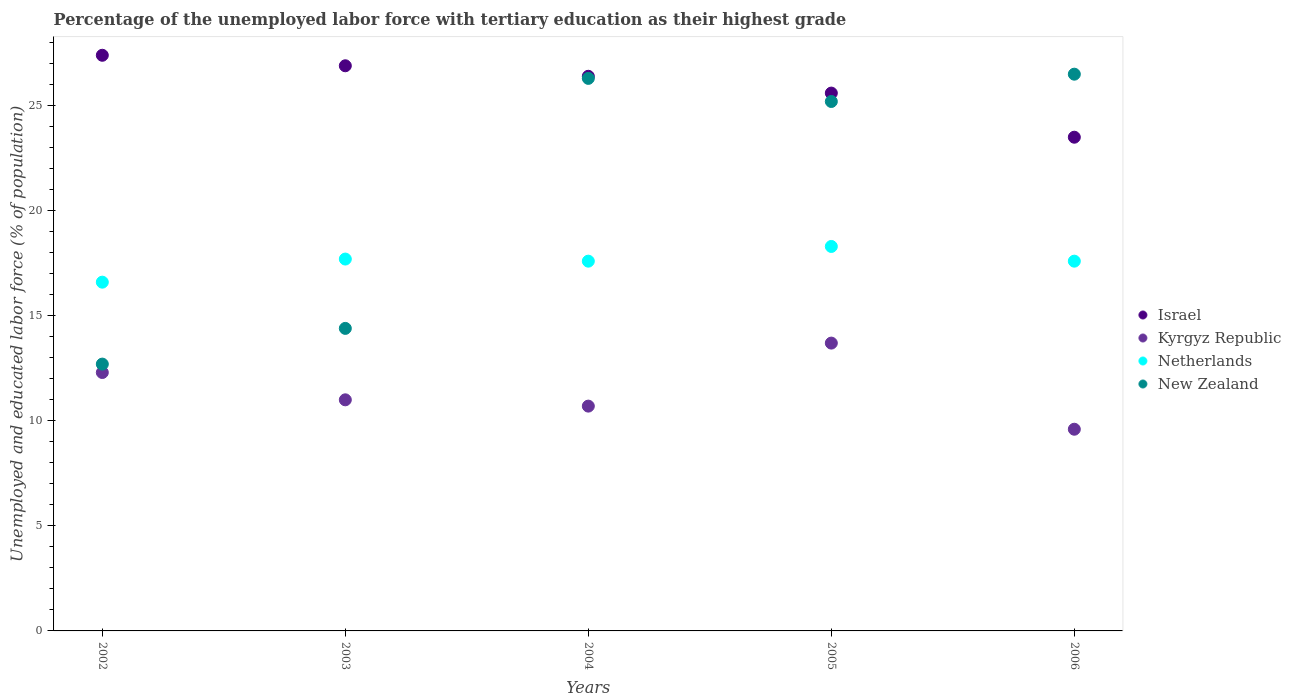How many different coloured dotlines are there?
Provide a short and direct response. 4. Is the number of dotlines equal to the number of legend labels?
Provide a short and direct response. Yes. What is the percentage of the unemployed labor force with tertiary education in Kyrgyz Republic in 2005?
Provide a succinct answer. 13.7. Across all years, what is the maximum percentage of the unemployed labor force with tertiary education in Kyrgyz Republic?
Your answer should be very brief. 13.7. Across all years, what is the minimum percentage of the unemployed labor force with tertiary education in Kyrgyz Republic?
Offer a very short reply. 9.6. In which year was the percentage of the unemployed labor force with tertiary education in Israel minimum?
Make the answer very short. 2006. What is the total percentage of the unemployed labor force with tertiary education in Kyrgyz Republic in the graph?
Provide a short and direct response. 57.3. What is the difference between the percentage of the unemployed labor force with tertiary education in Israel in 2004 and that in 2006?
Your answer should be compact. 2.9. What is the difference between the percentage of the unemployed labor force with tertiary education in Netherlands in 2002 and the percentage of the unemployed labor force with tertiary education in Israel in 2003?
Ensure brevity in your answer.  -10.3. What is the average percentage of the unemployed labor force with tertiary education in Netherlands per year?
Give a very brief answer. 17.56. In the year 2003, what is the difference between the percentage of the unemployed labor force with tertiary education in Israel and percentage of the unemployed labor force with tertiary education in New Zealand?
Keep it short and to the point. 12.5. In how many years, is the percentage of the unemployed labor force with tertiary education in Israel greater than 21 %?
Your answer should be compact. 5. What is the ratio of the percentage of the unemployed labor force with tertiary education in Israel in 2002 to that in 2006?
Your answer should be very brief. 1.17. What is the difference between the highest and the second highest percentage of the unemployed labor force with tertiary education in Israel?
Keep it short and to the point. 0.5. What is the difference between the highest and the lowest percentage of the unemployed labor force with tertiary education in Netherlands?
Your answer should be very brief. 1.7. In how many years, is the percentage of the unemployed labor force with tertiary education in Kyrgyz Republic greater than the average percentage of the unemployed labor force with tertiary education in Kyrgyz Republic taken over all years?
Your answer should be very brief. 2. Is the sum of the percentage of the unemployed labor force with tertiary education in Netherlands in 2003 and 2005 greater than the maximum percentage of the unemployed labor force with tertiary education in Kyrgyz Republic across all years?
Provide a succinct answer. Yes. Is it the case that in every year, the sum of the percentage of the unemployed labor force with tertiary education in Netherlands and percentage of the unemployed labor force with tertiary education in New Zealand  is greater than the sum of percentage of the unemployed labor force with tertiary education in Israel and percentage of the unemployed labor force with tertiary education in Kyrgyz Republic?
Ensure brevity in your answer.  No. Is it the case that in every year, the sum of the percentage of the unemployed labor force with tertiary education in New Zealand and percentage of the unemployed labor force with tertiary education in Kyrgyz Republic  is greater than the percentage of the unemployed labor force with tertiary education in Netherlands?
Offer a terse response. Yes. Does the percentage of the unemployed labor force with tertiary education in Kyrgyz Republic monotonically increase over the years?
Offer a terse response. No. Is the percentage of the unemployed labor force with tertiary education in Israel strictly greater than the percentage of the unemployed labor force with tertiary education in New Zealand over the years?
Your answer should be compact. No. Is the percentage of the unemployed labor force with tertiary education in Israel strictly less than the percentage of the unemployed labor force with tertiary education in New Zealand over the years?
Ensure brevity in your answer.  No. How many dotlines are there?
Provide a short and direct response. 4. Are the values on the major ticks of Y-axis written in scientific E-notation?
Your response must be concise. No. Does the graph contain any zero values?
Give a very brief answer. No. Where does the legend appear in the graph?
Provide a short and direct response. Center right. How are the legend labels stacked?
Give a very brief answer. Vertical. What is the title of the graph?
Make the answer very short. Percentage of the unemployed labor force with tertiary education as their highest grade. Does "Grenada" appear as one of the legend labels in the graph?
Offer a terse response. No. What is the label or title of the Y-axis?
Your response must be concise. Unemployed and educated labor force (% of population). What is the Unemployed and educated labor force (% of population) of Israel in 2002?
Provide a short and direct response. 27.4. What is the Unemployed and educated labor force (% of population) in Kyrgyz Republic in 2002?
Offer a terse response. 12.3. What is the Unemployed and educated labor force (% of population) of Netherlands in 2002?
Ensure brevity in your answer.  16.6. What is the Unemployed and educated labor force (% of population) of New Zealand in 2002?
Your answer should be very brief. 12.7. What is the Unemployed and educated labor force (% of population) in Israel in 2003?
Give a very brief answer. 26.9. What is the Unemployed and educated labor force (% of population) in Netherlands in 2003?
Your response must be concise. 17.7. What is the Unemployed and educated labor force (% of population) of New Zealand in 2003?
Your response must be concise. 14.4. What is the Unemployed and educated labor force (% of population) in Israel in 2004?
Offer a terse response. 26.4. What is the Unemployed and educated labor force (% of population) in Kyrgyz Republic in 2004?
Give a very brief answer. 10.7. What is the Unemployed and educated labor force (% of population) of Netherlands in 2004?
Give a very brief answer. 17.6. What is the Unemployed and educated labor force (% of population) of New Zealand in 2004?
Offer a terse response. 26.3. What is the Unemployed and educated labor force (% of population) of Israel in 2005?
Offer a terse response. 25.6. What is the Unemployed and educated labor force (% of population) of Kyrgyz Republic in 2005?
Provide a succinct answer. 13.7. What is the Unemployed and educated labor force (% of population) of Netherlands in 2005?
Offer a very short reply. 18.3. What is the Unemployed and educated labor force (% of population) in New Zealand in 2005?
Provide a short and direct response. 25.2. What is the Unemployed and educated labor force (% of population) in Kyrgyz Republic in 2006?
Keep it short and to the point. 9.6. What is the Unemployed and educated labor force (% of population) of Netherlands in 2006?
Your response must be concise. 17.6. What is the Unemployed and educated labor force (% of population) in New Zealand in 2006?
Your answer should be very brief. 26.5. Across all years, what is the maximum Unemployed and educated labor force (% of population) of Israel?
Your response must be concise. 27.4. Across all years, what is the maximum Unemployed and educated labor force (% of population) in Kyrgyz Republic?
Keep it short and to the point. 13.7. Across all years, what is the maximum Unemployed and educated labor force (% of population) in Netherlands?
Offer a very short reply. 18.3. Across all years, what is the minimum Unemployed and educated labor force (% of population) in Kyrgyz Republic?
Offer a terse response. 9.6. Across all years, what is the minimum Unemployed and educated labor force (% of population) in Netherlands?
Give a very brief answer. 16.6. Across all years, what is the minimum Unemployed and educated labor force (% of population) of New Zealand?
Your response must be concise. 12.7. What is the total Unemployed and educated labor force (% of population) of Israel in the graph?
Give a very brief answer. 129.8. What is the total Unemployed and educated labor force (% of population) in Kyrgyz Republic in the graph?
Your answer should be very brief. 57.3. What is the total Unemployed and educated labor force (% of population) of Netherlands in the graph?
Provide a succinct answer. 87.8. What is the total Unemployed and educated labor force (% of population) of New Zealand in the graph?
Offer a very short reply. 105.1. What is the difference between the Unemployed and educated labor force (% of population) in Israel in 2002 and that in 2003?
Your answer should be very brief. 0.5. What is the difference between the Unemployed and educated labor force (% of population) of Netherlands in 2002 and that in 2003?
Ensure brevity in your answer.  -1.1. What is the difference between the Unemployed and educated labor force (% of population) of New Zealand in 2002 and that in 2004?
Your response must be concise. -13.6. What is the difference between the Unemployed and educated labor force (% of population) in Israel in 2002 and that in 2005?
Provide a succinct answer. 1.8. What is the difference between the Unemployed and educated labor force (% of population) of Kyrgyz Republic in 2002 and that in 2005?
Give a very brief answer. -1.4. What is the difference between the Unemployed and educated labor force (% of population) of Netherlands in 2002 and that in 2005?
Your response must be concise. -1.7. What is the difference between the Unemployed and educated labor force (% of population) of Israel in 2002 and that in 2006?
Your answer should be very brief. 3.9. What is the difference between the Unemployed and educated labor force (% of population) in Netherlands in 2002 and that in 2006?
Your response must be concise. -1. What is the difference between the Unemployed and educated labor force (% of population) in New Zealand in 2002 and that in 2006?
Offer a terse response. -13.8. What is the difference between the Unemployed and educated labor force (% of population) in Israel in 2003 and that in 2004?
Make the answer very short. 0.5. What is the difference between the Unemployed and educated labor force (% of population) of New Zealand in 2003 and that in 2004?
Your response must be concise. -11.9. What is the difference between the Unemployed and educated labor force (% of population) of Israel in 2003 and that in 2005?
Ensure brevity in your answer.  1.3. What is the difference between the Unemployed and educated labor force (% of population) of Netherlands in 2003 and that in 2005?
Your response must be concise. -0.6. What is the difference between the Unemployed and educated labor force (% of population) in Israel in 2004 and that in 2006?
Ensure brevity in your answer.  2.9. What is the difference between the Unemployed and educated labor force (% of population) of Netherlands in 2004 and that in 2006?
Your answer should be very brief. 0. What is the difference between the Unemployed and educated labor force (% of population) in New Zealand in 2005 and that in 2006?
Your response must be concise. -1.3. What is the difference between the Unemployed and educated labor force (% of population) in Israel in 2002 and the Unemployed and educated labor force (% of population) in Kyrgyz Republic in 2003?
Offer a very short reply. 16.4. What is the difference between the Unemployed and educated labor force (% of population) of Israel in 2002 and the Unemployed and educated labor force (% of population) of New Zealand in 2003?
Your response must be concise. 13. What is the difference between the Unemployed and educated labor force (% of population) in Kyrgyz Republic in 2002 and the Unemployed and educated labor force (% of population) in Netherlands in 2003?
Ensure brevity in your answer.  -5.4. What is the difference between the Unemployed and educated labor force (% of population) of Kyrgyz Republic in 2002 and the Unemployed and educated labor force (% of population) of New Zealand in 2003?
Give a very brief answer. -2.1. What is the difference between the Unemployed and educated labor force (% of population) in Netherlands in 2002 and the Unemployed and educated labor force (% of population) in New Zealand in 2003?
Ensure brevity in your answer.  2.2. What is the difference between the Unemployed and educated labor force (% of population) in Israel in 2002 and the Unemployed and educated labor force (% of population) in New Zealand in 2004?
Keep it short and to the point. 1.1. What is the difference between the Unemployed and educated labor force (% of population) of Kyrgyz Republic in 2002 and the Unemployed and educated labor force (% of population) of Netherlands in 2004?
Make the answer very short. -5.3. What is the difference between the Unemployed and educated labor force (% of population) of Kyrgyz Republic in 2002 and the Unemployed and educated labor force (% of population) of New Zealand in 2004?
Your answer should be compact. -14. What is the difference between the Unemployed and educated labor force (% of population) in Israel in 2002 and the Unemployed and educated labor force (% of population) in Kyrgyz Republic in 2005?
Your answer should be compact. 13.7. What is the difference between the Unemployed and educated labor force (% of population) in Kyrgyz Republic in 2002 and the Unemployed and educated labor force (% of population) in Netherlands in 2005?
Your answer should be very brief. -6. What is the difference between the Unemployed and educated labor force (% of population) in Kyrgyz Republic in 2002 and the Unemployed and educated labor force (% of population) in New Zealand in 2005?
Make the answer very short. -12.9. What is the difference between the Unemployed and educated labor force (% of population) of Israel in 2002 and the Unemployed and educated labor force (% of population) of Kyrgyz Republic in 2006?
Offer a very short reply. 17.8. What is the difference between the Unemployed and educated labor force (% of population) of Israel in 2002 and the Unemployed and educated labor force (% of population) of Netherlands in 2006?
Provide a short and direct response. 9.8. What is the difference between the Unemployed and educated labor force (% of population) of Israel in 2002 and the Unemployed and educated labor force (% of population) of New Zealand in 2006?
Offer a terse response. 0.9. What is the difference between the Unemployed and educated labor force (% of population) in Kyrgyz Republic in 2002 and the Unemployed and educated labor force (% of population) in Netherlands in 2006?
Your response must be concise. -5.3. What is the difference between the Unemployed and educated labor force (% of population) of Kyrgyz Republic in 2002 and the Unemployed and educated labor force (% of population) of New Zealand in 2006?
Provide a succinct answer. -14.2. What is the difference between the Unemployed and educated labor force (% of population) of Israel in 2003 and the Unemployed and educated labor force (% of population) of Kyrgyz Republic in 2004?
Keep it short and to the point. 16.2. What is the difference between the Unemployed and educated labor force (% of population) in Kyrgyz Republic in 2003 and the Unemployed and educated labor force (% of population) in Netherlands in 2004?
Give a very brief answer. -6.6. What is the difference between the Unemployed and educated labor force (% of population) of Kyrgyz Republic in 2003 and the Unemployed and educated labor force (% of population) of New Zealand in 2004?
Offer a terse response. -15.3. What is the difference between the Unemployed and educated labor force (% of population) in Netherlands in 2003 and the Unemployed and educated labor force (% of population) in New Zealand in 2004?
Give a very brief answer. -8.6. What is the difference between the Unemployed and educated labor force (% of population) of Israel in 2003 and the Unemployed and educated labor force (% of population) of Kyrgyz Republic in 2005?
Offer a terse response. 13.2. What is the difference between the Unemployed and educated labor force (% of population) in Israel in 2003 and the Unemployed and educated labor force (% of population) in Netherlands in 2005?
Make the answer very short. 8.6. What is the difference between the Unemployed and educated labor force (% of population) of Israel in 2003 and the Unemployed and educated labor force (% of population) of New Zealand in 2005?
Your answer should be very brief. 1.7. What is the difference between the Unemployed and educated labor force (% of population) of Kyrgyz Republic in 2003 and the Unemployed and educated labor force (% of population) of Netherlands in 2005?
Provide a short and direct response. -7.3. What is the difference between the Unemployed and educated labor force (% of population) in Kyrgyz Republic in 2003 and the Unemployed and educated labor force (% of population) in New Zealand in 2005?
Offer a terse response. -14.2. What is the difference between the Unemployed and educated labor force (% of population) of Netherlands in 2003 and the Unemployed and educated labor force (% of population) of New Zealand in 2005?
Provide a short and direct response. -7.5. What is the difference between the Unemployed and educated labor force (% of population) of Israel in 2003 and the Unemployed and educated labor force (% of population) of Kyrgyz Republic in 2006?
Your answer should be compact. 17.3. What is the difference between the Unemployed and educated labor force (% of population) in Israel in 2003 and the Unemployed and educated labor force (% of population) in Netherlands in 2006?
Provide a succinct answer. 9.3. What is the difference between the Unemployed and educated labor force (% of population) of Kyrgyz Republic in 2003 and the Unemployed and educated labor force (% of population) of New Zealand in 2006?
Your answer should be compact. -15.5. What is the difference between the Unemployed and educated labor force (% of population) in Netherlands in 2003 and the Unemployed and educated labor force (% of population) in New Zealand in 2006?
Ensure brevity in your answer.  -8.8. What is the difference between the Unemployed and educated labor force (% of population) of Israel in 2004 and the Unemployed and educated labor force (% of population) of Kyrgyz Republic in 2005?
Your answer should be very brief. 12.7. What is the difference between the Unemployed and educated labor force (% of population) in Israel in 2004 and the Unemployed and educated labor force (% of population) in New Zealand in 2005?
Ensure brevity in your answer.  1.2. What is the difference between the Unemployed and educated labor force (% of population) in Kyrgyz Republic in 2004 and the Unemployed and educated labor force (% of population) in New Zealand in 2005?
Offer a very short reply. -14.5. What is the difference between the Unemployed and educated labor force (% of population) in Netherlands in 2004 and the Unemployed and educated labor force (% of population) in New Zealand in 2005?
Ensure brevity in your answer.  -7.6. What is the difference between the Unemployed and educated labor force (% of population) in Israel in 2004 and the Unemployed and educated labor force (% of population) in Netherlands in 2006?
Provide a succinct answer. 8.8. What is the difference between the Unemployed and educated labor force (% of population) of Kyrgyz Republic in 2004 and the Unemployed and educated labor force (% of population) of Netherlands in 2006?
Provide a short and direct response. -6.9. What is the difference between the Unemployed and educated labor force (% of population) of Kyrgyz Republic in 2004 and the Unemployed and educated labor force (% of population) of New Zealand in 2006?
Your response must be concise. -15.8. What is the difference between the Unemployed and educated labor force (% of population) of Netherlands in 2004 and the Unemployed and educated labor force (% of population) of New Zealand in 2006?
Keep it short and to the point. -8.9. What is the difference between the Unemployed and educated labor force (% of population) of Israel in 2005 and the Unemployed and educated labor force (% of population) of Kyrgyz Republic in 2006?
Ensure brevity in your answer.  16. What is the difference between the Unemployed and educated labor force (% of population) of Israel in 2005 and the Unemployed and educated labor force (% of population) of Netherlands in 2006?
Offer a very short reply. 8. What is the difference between the Unemployed and educated labor force (% of population) of Netherlands in 2005 and the Unemployed and educated labor force (% of population) of New Zealand in 2006?
Keep it short and to the point. -8.2. What is the average Unemployed and educated labor force (% of population) of Israel per year?
Ensure brevity in your answer.  25.96. What is the average Unemployed and educated labor force (% of population) of Kyrgyz Republic per year?
Ensure brevity in your answer.  11.46. What is the average Unemployed and educated labor force (% of population) of Netherlands per year?
Offer a terse response. 17.56. What is the average Unemployed and educated labor force (% of population) in New Zealand per year?
Offer a terse response. 21.02. In the year 2002, what is the difference between the Unemployed and educated labor force (% of population) of Israel and Unemployed and educated labor force (% of population) of New Zealand?
Provide a short and direct response. 14.7. In the year 2002, what is the difference between the Unemployed and educated labor force (% of population) in Kyrgyz Republic and Unemployed and educated labor force (% of population) in Netherlands?
Your response must be concise. -4.3. In the year 2002, what is the difference between the Unemployed and educated labor force (% of population) in Kyrgyz Republic and Unemployed and educated labor force (% of population) in New Zealand?
Offer a very short reply. -0.4. In the year 2002, what is the difference between the Unemployed and educated labor force (% of population) in Netherlands and Unemployed and educated labor force (% of population) in New Zealand?
Your answer should be compact. 3.9. In the year 2003, what is the difference between the Unemployed and educated labor force (% of population) in Israel and Unemployed and educated labor force (% of population) in Kyrgyz Republic?
Ensure brevity in your answer.  15.9. In the year 2003, what is the difference between the Unemployed and educated labor force (% of population) in Israel and Unemployed and educated labor force (% of population) in Netherlands?
Your answer should be compact. 9.2. In the year 2003, what is the difference between the Unemployed and educated labor force (% of population) of Kyrgyz Republic and Unemployed and educated labor force (% of population) of New Zealand?
Ensure brevity in your answer.  -3.4. In the year 2003, what is the difference between the Unemployed and educated labor force (% of population) in Netherlands and Unemployed and educated labor force (% of population) in New Zealand?
Make the answer very short. 3.3. In the year 2004, what is the difference between the Unemployed and educated labor force (% of population) of Israel and Unemployed and educated labor force (% of population) of Netherlands?
Your answer should be very brief. 8.8. In the year 2004, what is the difference between the Unemployed and educated labor force (% of population) in Israel and Unemployed and educated labor force (% of population) in New Zealand?
Make the answer very short. 0.1. In the year 2004, what is the difference between the Unemployed and educated labor force (% of population) in Kyrgyz Republic and Unemployed and educated labor force (% of population) in Netherlands?
Provide a short and direct response. -6.9. In the year 2004, what is the difference between the Unemployed and educated labor force (% of population) of Kyrgyz Republic and Unemployed and educated labor force (% of population) of New Zealand?
Your response must be concise. -15.6. In the year 2004, what is the difference between the Unemployed and educated labor force (% of population) of Netherlands and Unemployed and educated labor force (% of population) of New Zealand?
Give a very brief answer. -8.7. In the year 2005, what is the difference between the Unemployed and educated labor force (% of population) of Israel and Unemployed and educated labor force (% of population) of Netherlands?
Make the answer very short. 7.3. In the year 2005, what is the difference between the Unemployed and educated labor force (% of population) of Israel and Unemployed and educated labor force (% of population) of New Zealand?
Ensure brevity in your answer.  0.4. In the year 2005, what is the difference between the Unemployed and educated labor force (% of population) in Kyrgyz Republic and Unemployed and educated labor force (% of population) in Netherlands?
Provide a succinct answer. -4.6. In the year 2005, what is the difference between the Unemployed and educated labor force (% of population) of Kyrgyz Republic and Unemployed and educated labor force (% of population) of New Zealand?
Keep it short and to the point. -11.5. In the year 2005, what is the difference between the Unemployed and educated labor force (% of population) of Netherlands and Unemployed and educated labor force (% of population) of New Zealand?
Provide a short and direct response. -6.9. In the year 2006, what is the difference between the Unemployed and educated labor force (% of population) in Israel and Unemployed and educated labor force (% of population) in Kyrgyz Republic?
Your response must be concise. 13.9. In the year 2006, what is the difference between the Unemployed and educated labor force (% of population) in Israel and Unemployed and educated labor force (% of population) in Netherlands?
Offer a terse response. 5.9. In the year 2006, what is the difference between the Unemployed and educated labor force (% of population) in Kyrgyz Republic and Unemployed and educated labor force (% of population) in Netherlands?
Ensure brevity in your answer.  -8. In the year 2006, what is the difference between the Unemployed and educated labor force (% of population) of Kyrgyz Republic and Unemployed and educated labor force (% of population) of New Zealand?
Offer a terse response. -16.9. What is the ratio of the Unemployed and educated labor force (% of population) in Israel in 2002 to that in 2003?
Offer a very short reply. 1.02. What is the ratio of the Unemployed and educated labor force (% of population) of Kyrgyz Republic in 2002 to that in 2003?
Offer a terse response. 1.12. What is the ratio of the Unemployed and educated labor force (% of population) of Netherlands in 2002 to that in 2003?
Provide a succinct answer. 0.94. What is the ratio of the Unemployed and educated labor force (% of population) in New Zealand in 2002 to that in 2003?
Your answer should be compact. 0.88. What is the ratio of the Unemployed and educated labor force (% of population) in Israel in 2002 to that in 2004?
Keep it short and to the point. 1.04. What is the ratio of the Unemployed and educated labor force (% of population) in Kyrgyz Republic in 2002 to that in 2004?
Give a very brief answer. 1.15. What is the ratio of the Unemployed and educated labor force (% of population) in Netherlands in 2002 to that in 2004?
Your response must be concise. 0.94. What is the ratio of the Unemployed and educated labor force (% of population) of New Zealand in 2002 to that in 2004?
Your answer should be very brief. 0.48. What is the ratio of the Unemployed and educated labor force (% of population) of Israel in 2002 to that in 2005?
Make the answer very short. 1.07. What is the ratio of the Unemployed and educated labor force (% of population) in Kyrgyz Republic in 2002 to that in 2005?
Give a very brief answer. 0.9. What is the ratio of the Unemployed and educated labor force (% of population) in Netherlands in 2002 to that in 2005?
Give a very brief answer. 0.91. What is the ratio of the Unemployed and educated labor force (% of population) of New Zealand in 2002 to that in 2005?
Keep it short and to the point. 0.5. What is the ratio of the Unemployed and educated labor force (% of population) in Israel in 2002 to that in 2006?
Offer a terse response. 1.17. What is the ratio of the Unemployed and educated labor force (% of population) of Kyrgyz Republic in 2002 to that in 2006?
Offer a terse response. 1.28. What is the ratio of the Unemployed and educated labor force (% of population) in Netherlands in 2002 to that in 2006?
Your answer should be compact. 0.94. What is the ratio of the Unemployed and educated labor force (% of population) of New Zealand in 2002 to that in 2006?
Your response must be concise. 0.48. What is the ratio of the Unemployed and educated labor force (% of population) in Israel in 2003 to that in 2004?
Your response must be concise. 1.02. What is the ratio of the Unemployed and educated labor force (% of population) in Kyrgyz Republic in 2003 to that in 2004?
Provide a succinct answer. 1.03. What is the ratio of the Unemployed and educated labor force (% of population) of Netherlands in 2003 to that in 2004?
Offer a terse response. 1.01. What is the ratio of the Unemployed and educated labor force (% of population) in New Zealand in 2003 to that in 2004?
Ensure brevity in your answer.  0.55. What is the ratio of the Unemployed and educated labor force (% of population) of Israel in 2003 to that in 2005?
Your answer should be compact. 1.05. What is the ratio of the Unemployed and educated labor force (% of population) of Kyrgyz Republic in 2003 to that in 2005?
Provide a short and direct response. 0.8. What is the ratio of the Unemployed and educated labor force (% of population) of Netherlands in 2003 to that in 2005?
Offer a very short reply. 0.97. What is the ratio of the Unemployed and educated labor force (% of population) in Israel in 2003 to that in 2006?
Give a very brief answer. 1.14. What is the ratio of the Unemployed and educated labor force (% of population) of Kyrgyz Republic in 2003 to that in 2006?
Give a very brief answer. 1.15. What is the ratio of the Unemployed and educated labor force (% of population) of New Zealand in 2003 to that in 2006?
Your response must be concise. 0.54. What is the ratio of the Unemployed and educated labor force (% of population) in Israel in 2004 to that in 2005?
Provide a short and direct response. 1.03. What is the ratio of the Unemployed and educated labor force (% of population) in Kyrgyz Republic in 2004 to that in 2005?
Provide a short and direct response. 0.78. What is the ratio of the Unemployed and educated labor force (% of population) in Netherlands in 2004 to that in 2005?
Provide a short and direct response. 0.96. What is the ratio of the Unemployed and educated labor force (% of population) of New Zealand in 2004 to that in 2005?
Offer a terse response. 1.04. What is the ratio of the Unemployed and educated labor force (% of population) in Israel in 2004 to that in 2006?
Keep it short and to the point. 1.12. What is the ratio of the Unemployed and educated labor force (% of population) in Kyrgyz Republic in 2004 to that in 2006?
Make the answer very short. 1.11. What is the ratio of the Unemployed and educated labor force (% of population) in Netherlands in 2004 to that in 2006?
Keep it short and to the point. 1. What is the ratio of the Unemployed and educated labor force (% of population) of Israel in 2005 to that in 2006?
Your answer should be compact. 1.09. What is the ratio of the Unemployed and educated labor force (% of population) in Kyrgyz Republic in 2005 to that in 2006?
Your answer should be very brief. 1.43. What is the ratio of the Unemployed and educated labor force (% of population) in Netherlands in 2005 to that in 2006?
Offer a terse response. 1.04. What is the ratio of the Unemployed and educated labor force (% of population) of New Zealand in 2005 to that in 2006?
Your answer should be very brief. 0.95. What is the difference between the highest and the second highest Unemployed and educated labor force (% of population) in Israel?
Offer a very short reply. 0.5. What is the difference between the highest and the second highest Unemployed and educated labor force (% of population) in Netherlands?
Ensure brevity in your answer.  0.6. What is the difference between the highest and the lowest Unemployed and educated labor force (% of population) in Israel?
Offer a terse response. 3.9. What is the difference between the highest and the lowest Unemployed and educated labor force (% of population) in Kyrgyz Republic?
Offer a very short reply. 4.1. What is the difference between the highest and the lowest Unemployed and educated labor force (% of population) of Netherlands?
Offer a very short reply. 1.7. What is the difference between the highest and the lowest Unemployed and educated labor force (% of population) of New Zealand?
Your response must be concise. 13.8. 